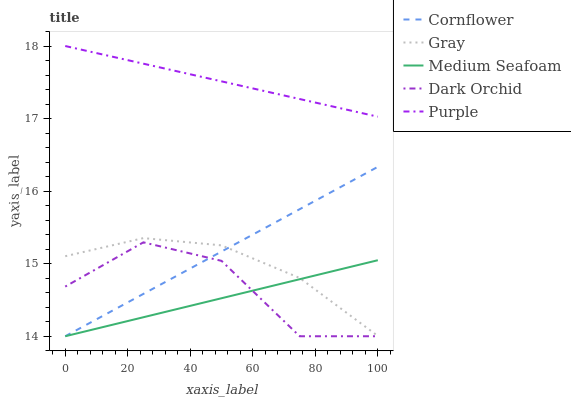Does Medium Seafoam have the minimum area under the curve?
Answer yes or no. Yes. Does Purple have the maximum area under the curve?
Answer yes or no. Yes. Does Cornflower have the minimum area under the curve?
Answer yes or no. No. Does Cornflower have the maximum area under the curve?
Answer yes or no. No. Is Cornflower the smoothest?
Answer yes or no. Yes. Is Dark Orchid the roughest?
Answer yes or no. Yes. Is Medium Seafoam the smoothest?
Answer yes or no. No. Is Medium Seafoam the roughest?
Answer yes or no. No. Does Gray have the lowest value?
Answer yes or no. No. Does Cornflower have the highest value?
Answer yes or no. No. Is Cornflower less than Purple?
Answer yes or no. Yes. Is Gray greater than Dark Orchid?
Answer yes or no. Yes. Does Cornflower intersect Purple?
Answer yes or no. No. 